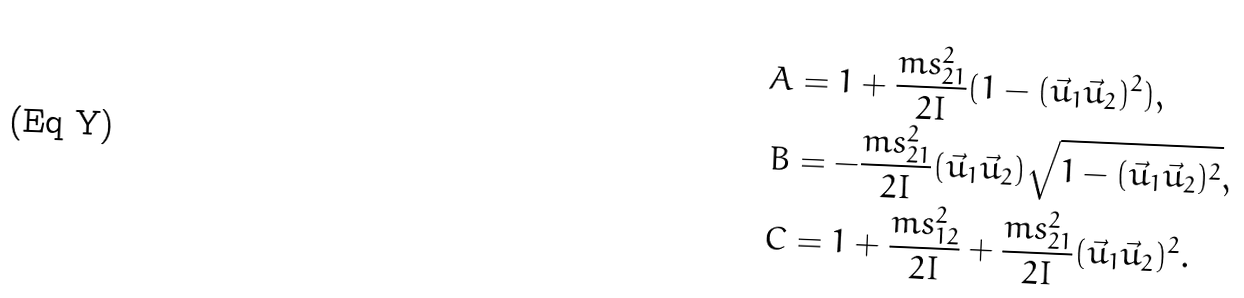Convert formula to latex. <formula><loc_0><loc_0><loc_500><loc_500>A & = 1 + \frac { m s _ { 2 1 } ^ { 2 } } { 2 I } ( 1 - ( \vec { u } _ { 1 } \vec { u } _ { 2 } ) ^ { 2 } ) , \\ B & = - \frac { m s _ { 2 1 } ^ { 2 } } { 2 I } ( \vec { u } _ { 1 } \vec { u } _ { 2 } ) \sqrt { 1 - ( \vec { u } _ { 1 } \vec { u } _ { 2 } ) ^ { 2 } } , \\ C & = 1 + \frac { m s _ { 1 2 } ^ { 2 } } { 2 I } + \frac { m s _ { 2 1 } ^ { 2 } } { 2 I } ( \vec { u } _ { 1 } \vec { u } _ { 2 } ) ^ { 2 } .</formula> 